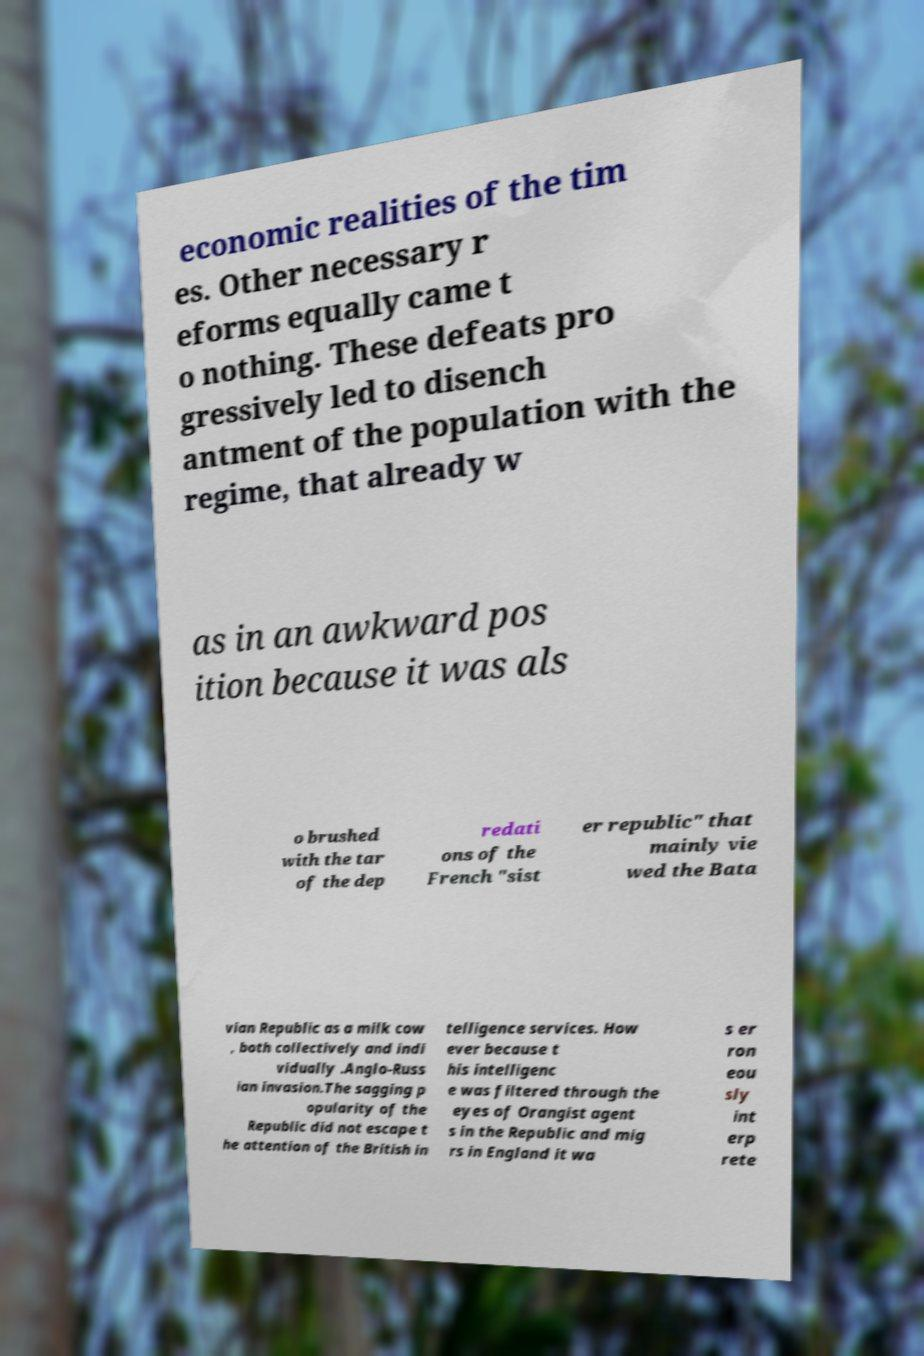What messages or text are displayed in this image? I need them in a readable, typed format. economic realities of the tim es. Other necessary r eforms equally came t o nothing. These defeats pro gressively led to disench antment of the population with the regime, that already w as in an awkward pos ition because it was als o brushed with the tar of the dep redati ons of the French "sist er republic" that mainly vie wed the Bata vian Republic as a milk cow , both collectively and indi vidually .Anglo-Russ ian invasion.The sagging p opularity of the Republic did not escape t he attention of the British in telligence services. How ever because t his intelligenc e was filtered through the eyes of Orangist agent s in the Republic and mig rs in England it wa s er ron eou sly int erp rete 